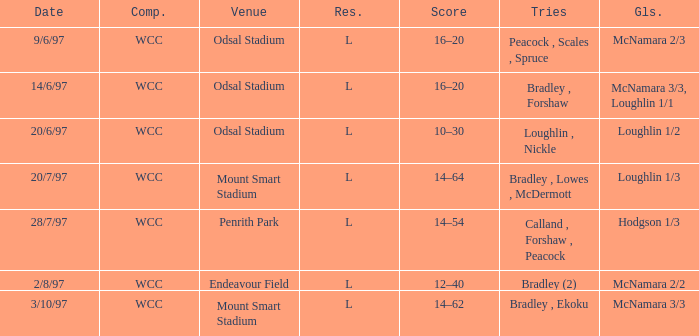What was the score on 20/6/97? 10–30. 